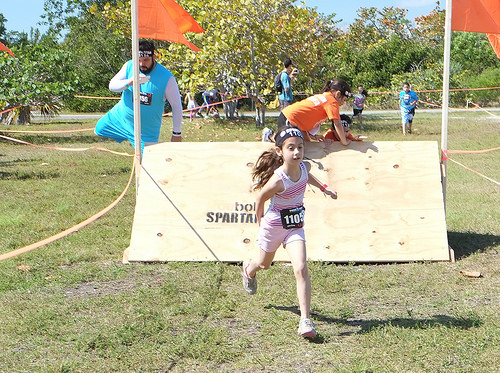<image>
Can you confirm if the bib is under the flag? No. The bib is not positioned under the flag. The vertical relationship between these objects is different. 